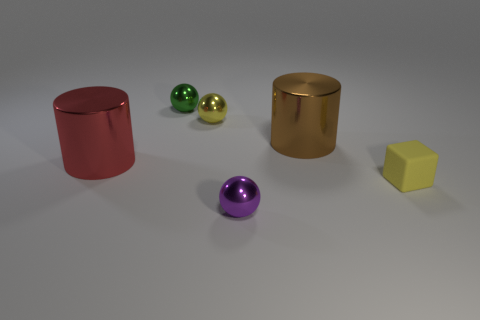Subtract all small yellow shiny balls. How many balls are left? 2 Add 3 big red cylinders. How many objects exist? 9 Subtract all red cylinders. How many cylinders are left? 1 Subtract 0 yellow cylinders. How many objects are left? 6 Subtract all cubes. How many objects are left? 5 Subtract 1 blocks. How many blocks are left? 0 Subtract all red cubes. Subtract all blue cylinders. How many cubes are left? 1 Subtract all yellow cubes. How many yellow balls are left? 1 Subtract all tiny spheres. Subtract all big brown objects. How many objects are left? 2 Add 5 tiny yellow shiny spheres. How many tiny yellow shiny spheres are left? 6 